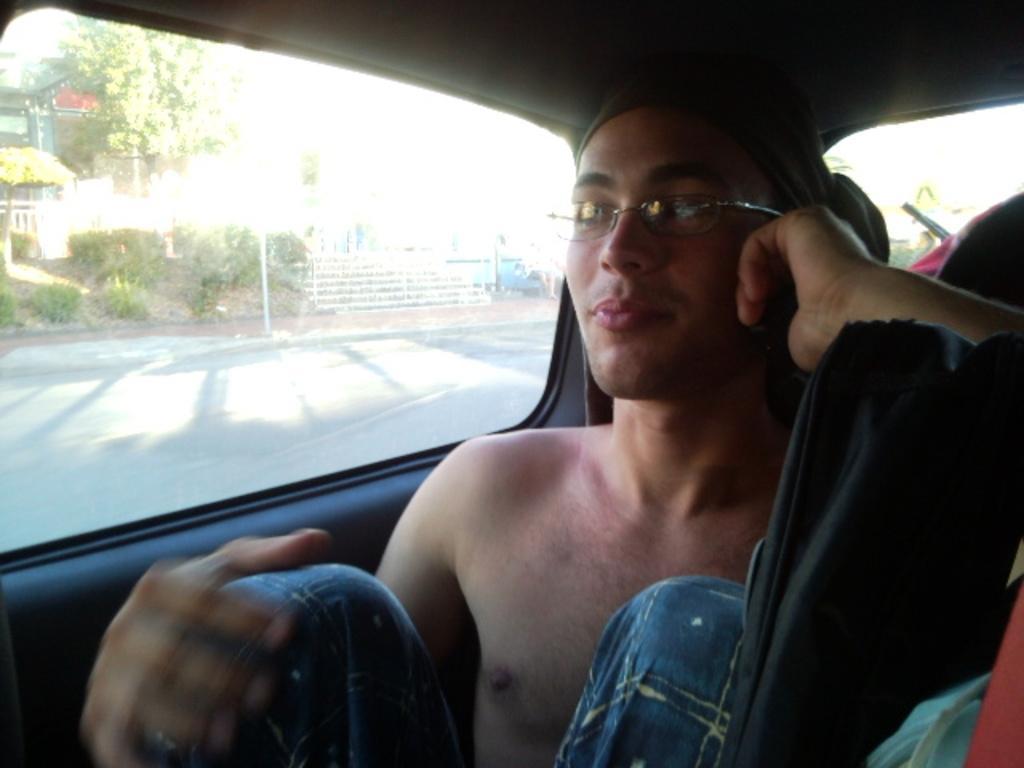In one or two sentences, can you explain what this image depicts? In this picture we can see a person sitting in a car. There are few objects in a car. We can see some trees, pole and buildings in the background. 